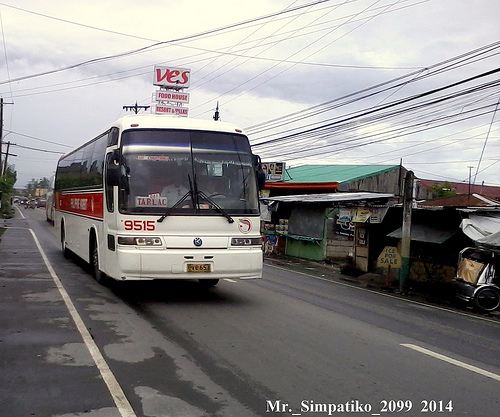<image>
Can you confirm if the sign is above the bus? No. The sign is not positioned above the bus. The vertical arrangement shows a different relationship. Where is the bus in relation to the dirt? Is it on the dirt? No. The bus is not positioned on the dirt. They may be near each other, but the bus is not supported by or resting on top of the dirt. 